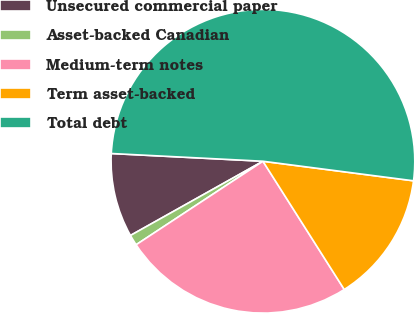<chart> <loc_0><loc_0><loc_500><loc_500><pie_chart><fcel>Unsecured commercial paper<fcel>Asset-backed Canadian<fcel>Medium-term notes<fcel>Term asset-backed<fcel>Total debt<nl><fcel>8.94%<fcel>1.14%<fcel>24.73%<fcel>13.95%<fcel>51.25%<nl></chart> 